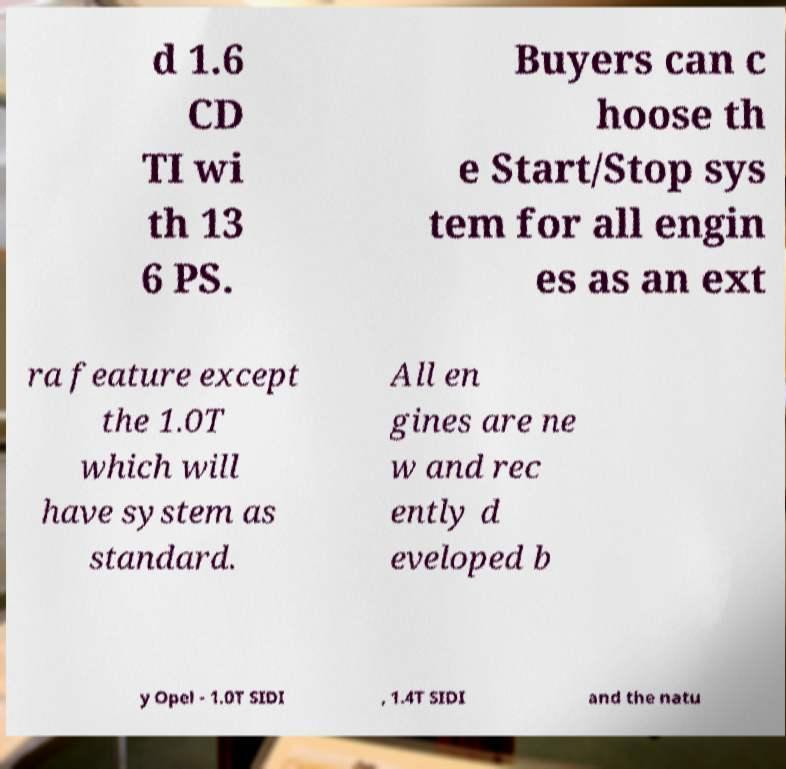Please read and relay the text visible in this image. What does it say? d 1.6 CD TI wi th 13 6 PS. Buyers can c hoose th e Start/Stop sys tem for all engin es as an ext ra feature except the 1.0T which will have system as standard. All en gines are ne w and rec ently d eveloped b y Opel - 1.0T SIDI , 1.4T SIDI and the natu 